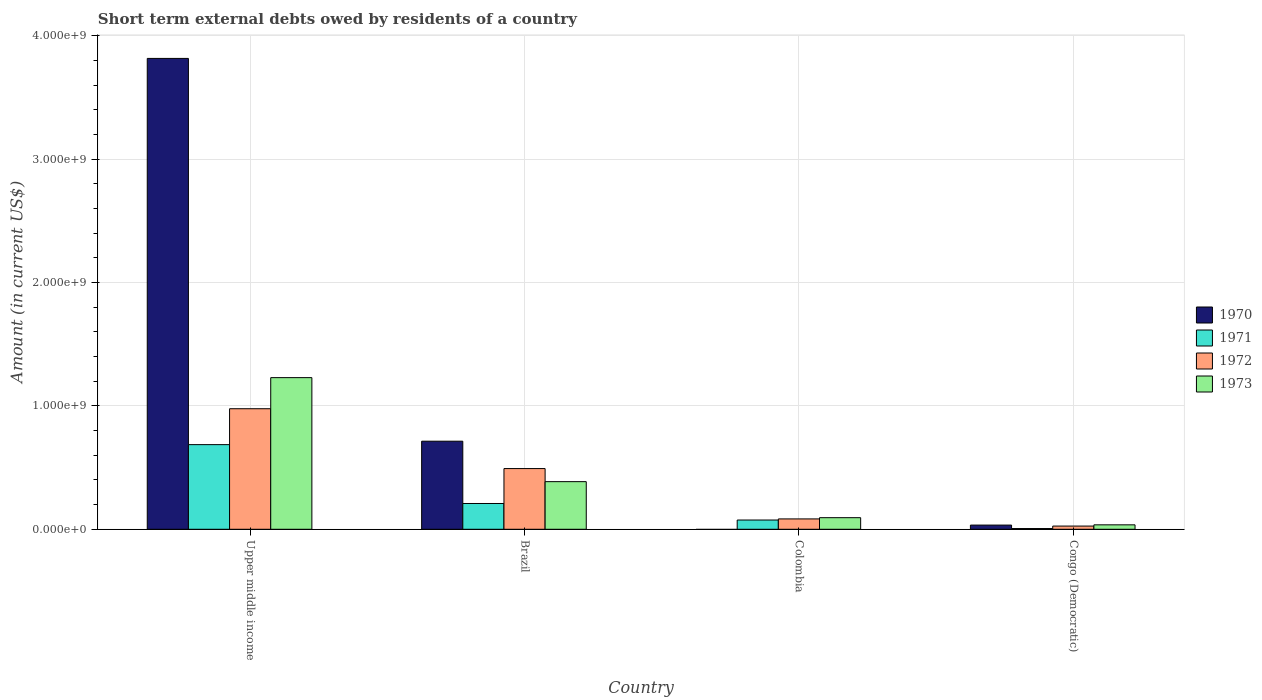How many bars are there on the 3rd tick from the left?
Your answer should be very brief. 3. How many bars are there on the 4th tick from the right?
Provide a succinct answer. 4. In how many cases, is the number of bars for a given country not equal to the number of legend labels?
Make the answer very short. 1. What is the amount of short-term external debts owed by residents in 1973 in Brazil?
Give a very brief answer. 3.86e+08. Across all countries, what is the maximum amount of short-term external debts owed by residents in 1971?
Make the answer very short. 6.86e+08. In which country was the amount of short-term external debts owed by residents in 1973 maximum?
Your answer should be compact. Upper middle income. What is the total amount of short-term external debts owed by residents in 1971 in the graph?
Ensure brevity in your answer.  9.76e+08. What is the difference between the amount of short-term external debts owed by residents in 1973 in Brazil and that in Colombia?
Make the answer very short. 2.92e+08. What is the difference between the amount of short-term external debts owed by residents in 1973 in Upper middle income and the amount of short-term external debts owed by residents in 1972 in Brazil?
Offer a terse response. 7.37e+08. What is the average amount of short-term external debts owed by residents in 1972 per country?
Give a very brief answer. 3.95e+08. What is the difference between the amount of short-term external debts owed by residents of/in 1972 and amount of short-term external debts owed by residents of/in 1970 in Congo (Democratic)?
Ensure brevity in your answer.  -8.00e+06. In how many countries, is the amount of short-term external debts owed by residents in 1970 greater than 1400000000 US$?
Your answer should be compact. 1. What is the ratio of the amount of short-term external debts owed by residents in 1973 in Colombia to that in Congo (Democratic)?
Your response must be concise. 2.61. What is the difference between the highest and the second highest amount of short-term external debts owed by residents in 1971?
Make the answer very short. 4.77e+08. What is the difference between the highest and the lowest amount of short-term external debts owed by residents in 1971?
Provide a short and direct response. 6.80e+08. Is it the case that in every country, the sum of the amount of short-term external debts owed by residents in 1972 and amount of short-term external debts owed by residents in 1971 is greater than the sum of amount of short-term external debts owed by residents in 1973 and amount of short-term external debts owed by residents in 1970?
Your response must be concise. No. Are the values on the major ticks of Y-axis written in scientific E-notation?
Give a very brief answer. Yes. Does the graph contain grids?
Give a very brief answer. Yes. Where does the legend appear in the graph?
Provide a succinct answer. Center right. How are the legend labels stacked?
Keep it short and to the point. Vertical. What is the title of the graph?
Your response must be concise. Short term external debts owed by residents of a country. Does "1994" appear as one of the legend labels in the graph?
Ensure brevity in your answer.  No. What is the label or title of the X-axis?
Provide a succinct answer. Country. What is the Amount (in current US$) of 1970 in Upper middle income?
Give a very brief answer. 3.82e+09. What is the Amount (in current US$) in 1971 in Upper middle income?
Provide a short and direct response. 6.86e+08. What is the Amount (in current US$) of 1972 in Upper middle income?
Ensure brevity in your answer.  9.77e+08. What is the Amount (in current US$) in 1973 in Upper middle income?
Ensure brevity in your answer.  1.23e+09. What is the Amount (in current US$) in 1970 in Brazil?
Offer a very short reply. 7.14e+08. What is the Amount (in current US$) of 1971 in Brazil?
Offer a terse response. 2.09e+08. What is the Amount (in current US$) in 1972 in Brazil?
Your answer should be compact. 4.92e+08. What is the Amount (in current US$) of 1973 in Brazil?
Offer a terse response. 3.86e+08. What is the Amount (in current US$) of 1970 in Colombia?
Your answer should be compact. 0. What is the Amount (in current US$) of 1971 in Colombia?
Offer a very short reply. 7.50e+07. What is the Amount (in current US$) of 1972 in Colombia?
Offer a very short reply. 8.40e+07. What is the Amount (in current US$) in 1973 in Colombia?
Ensure brevity in your answer.  9.40e+07. What is the Amount (in current US$) of 1970 in Congo (Democratic)?
Make the answer very short. 3.40e+07. What is the Amount (in current US$) in 1971 in Congo (Democratic)?
Make the answer very short. 6.00e+06. What is the Amount (in current US$) of 1972 in Congo (Democratic)?
Offer a terse response. 2.60e+07. What is the Amount (in current US$) of 1973 in Congo (Democratic)?
Your answer should be very brief. 3.60e+07. Across all countries, what is the maximum Amount (in current US$) in 1970?
Provide a succinct answer. 3.82e+09. Across all countries, what is the maximum Amount (in current US$) of 1971?
Provide a succinct answer. 6.86e+08. Across all countries, what is the maximum Amount (in current US$) of 1972?
Your answer should be very brief. 9.77e+08. Across all countries, what is the maximum Amount (in current US$) of 1973?
Give a very brief answer. 1.23e+09. Across all countries, what is the minimum Amount (in current US$) in 1970?
Keep it short and to the point. 0. Across all countries, what is the minimum Amount (in current US$) of 1972?
Give a very brief answer. 2.60e+07. Across all countries, what is the minimum Amount (in current US$) of 1973?
Make the answer very short. 3.60e+07. What is the total Amount (in current US$) of 1970 in the graph?
Offer a very short reply. 4.56e+09. What is the total Amount (in current US$) in 1971 in the graph?
Provide a succinct answer. 9.76e+08. What is the total Amount (in current US$) in 1972 in the graph?
Provide a short and direct response. 1.58e+09. What is the total Amount (in current US$) of 1973 in the graph?
Give a very brief answer. 1.75e+09. What is the difference between the Amount (in current US$) in 1970 in Upper middle income and that in Brazil?
Provide a short and direct response. 3.10e+09. What is the difference between the Amount (in current US$) of 1971 in Upper middle income and that in Brazil?
Make the answer very short. 4.77e+08. What is the difference between the Amount (in current US$) of 1972 in Upper middle income and that in Brazil?
Your response must be concise. 4.85e+08. What is the difference between the Amount (in current US$) of 1973 in Upper middle income and that in Brazil?
Offer a terse response. 8.43e+08. What is the difference between the Amount (in current US$) in 1971 in Upper middle income and that in Colombia?
Your answer should be compact. 6.11e+08. What is the difference between the Amount (in current US$) in 1972 in Upper middle income and that in Colombia?
Your answer should be very brief. 8.93e+08. What is the difference between the Amount (in current US$) of 1973 in Upper middle income and that in Colombia?
Ensure brevity in your answer.  1.14e+09. What is the difference between the Amount (in current US$) in 1970 in Upper middle income and that in Congo (Democratic)?
Keep it short and to the point. 3.78e+09. What is the difference between the Amount (in current US$) of 1971 in Upper middle income and that in Congo (Democratic)?
Offer a terse response. 6.80e+08. What is the difference between the Amount (in current US$) in 1972 in Upper middle income and that in Congo (Democratic)?
Keep it short and to the point. 9.51e+08. What is the difference between the Amount (in current US$) in 1973 in Upper middle income and that in Congo (Democratic)?
Provide a succinct answer. 1.19e+09. What is the difference between the Amount (in current US$) of 1971 in Brazil and that in Colombia?
Provide a short and direct response. 1.34e+08. What is the difference between the Amount (in current US$) of 1972 in Brazil and that in Colombia?
Keep it short and to the point. 4.08e+08. What is the difference between the Amount (in current US$) in 1973 in Brazil and that in Colombia?
Ensure brevity in your answer.  2.92e+08. What is the difference between the Amount (in current US$) of 1970 in Brazil and that in Congo (Democratic)?
Offer a very short reply. 6.80e+08. What is the difference between the Amount (in current US$) of 1971 in Brazil and that in Congo (Democratic)?
Your answer should be very brief. 2.03e+08. What is the difference between the Amount (in current US$) of 1972 in Brazil and that in Congo (Democratic)?
Your response must be concise. 4.66e+08. What is the difference between the Amount (in current US$) in 1973 in Brazil and that in Congo (Democratic)?
Offer a very short reply. 3.50e+08. What is the difference between the Amount (in current US$) of 1971 in Colombia and that in Congo (Democratic)?
Make the answer very short. 6.90e+07. What is the difference between the Amount (in current US$) of 1972 in Colombia and that in Congo (Democratic)?
Keep it short and to the point. 5.80e+07. What is the difference between the Amount (in current US$) of 1973 in Colombia and that in Congo (Democratic)?
Give a very brief answer. 5.80e+07. What is the difference between the Amount (in current US$) in 1970 in Upper middle income and the Amount (in current US$) in 1971 in Brazil?
Offer a terse response. 3.61e+09. What is the difference between the Amount (in current US$) of 1970 in Upper middle income and the Amount (in current US$) of 1972 in Brazil?
Make the answer very short. 3.32e+09. What is the difference between the Amount (in current US$) of 1970 in Upper middle income and the Amount (in current US$) of 1973 in Brazil?
Keep it short and to the point. 3.43e+09. What is the difference between the Amount (in current US$) in 1971 in Upper middle income and the Amount (in current US$) in 1972 in Brazil?
Ensure brevity in your answer.  1.94e+08. What is the difference between the Amount (in current US$) of 1971 in Upper middle income and the Amount (in current US$) of 1973 in Brazil?
Your response must be concise. 3.00e+08. What is the difference between the Amount (in current US$) in 1972 in Upper middle income and the Amount (in current US$) in 1973 in Brazil?
Keep it short and to the point. 5.91e+08. What is the difference between the Amount (in current US$) of 1970 in Upper middle income and the Amount (in current US$) of 1971 in Colombia?
Provide a succinct answer. 3.74e+09. What is the difference between the Amount (in current US$) of 1970 in Upper middle income and the Amount (in current US$) of 1972 in Colombia?
Provide a succinct answer. 3.73e+09. What is the difference between the Amount (in current US$) of 1970 in Upper middle income and the Amount (in current US$) of 1973 in Colombia?
Make the answer very short. 3.72e+09. What is the difference between the Amount (in current US$) of 1971 in Upper middle income and the Amount (in current US$) of 1972 in Colombia?
Keep it short and to the point. 6.02e+08. What is the difference between the Amount (in current US$) of 1971 in Upper middle income and the Amount (in current US$) of 1973 in Colombia?
Your answer should be very brief. 5.92e+08. What is the difference between the Amount (in current US$) in 1972 in Upper middle income and the Amount (in current US$) in 1973 in Colombia?
Provide a short and direct response. 8.83e+08. What is the difference between the Amount (in current US$) in 1970 in Upper middle income and the Amount (in current US$) in 1971 in Congo (Democratic)?
Give a very brief answer. 3.81e+09. What is the difference between the Amount (in current US$) of 1970 in Upper middle income and the Amount (in current US$) of 1972 in Congo (Democratic)?
Your answer should be very brief. 3.79e+09. What is the difference between the Amount (in current US$) in 1970 in Upper middle income and the Amount (in current US$) in 1973 in Congo (Democratic)?
Provide a short and direct response. 3.78e+09. What is the difference between the Amount (in current US$) of 1971 in Upper middle income and the Amount (in current US$) of 1972 in Congo (Democratic)?
Ensure brevity in your answer.  6.60e+08. What is the difference between the Amount (in current US$) of 1971 in Upper middle income and the Amount (in current US$) of 1973 in Congo (Democratic)?
Your answer should be compact. 6.50e+08. What is the difference between the Amount (in current US$) in 1972 in Upper middle income and the Amount (in current US$) in 1973 in Congo (Democratic)?
Give a very brief answer. 9.41e+08. What is the difference between the Amount (in current US$) in 1970 in Brazil and the Amount (in current US$) in 1971 in Colombia?
Keep it short and to the point. 6.39e+08. What is the difference between the Amount (in current US$) in 1970 in Brazil and the Amount (in current US$) in 1972 in Colombia?
Provide a succinct answer. 6.30e+08. What is the difference between the Amount (in current US$) of 1970 in Brazil and the Amount (in current US$) of 1973 in Colombia?
Your answer should be very brief. 6.20e+08. What is the difference between the Amount (in current US$) of 1971 in Brazil and the Amount (in current US$) of 1972 in Colombia?
Provide a short and direct response. 1.25e+08. What is the difference between the Amount (in current US$) in 1971 in Brazil and the Amount (in current US$) in 1973 in Colombia?
Make the answer very short. 1.15e+08. What is the difference between the Amount (in current US$) of 1972 in Brazil and the Amount (in current US$) of 1973 in Colombia?
Your response must be concise. 3.98e+08. What is the difference between the Amount (in current US$) in 1970 in Brazil and the Amount (in current US$) in 1971 in Congo (Democratic)?
Ensure brevity in your answer.  7.08e+08. What is the difference between the Amount (in current US$) of 1970 in Brazil and the Amount (in current US$) of 1972 in Congo (Democratic)?
Your response must be concise. 6.88e+08. What is the difference between the Amount (in current US$) in 1970 in Brazil and the Amount (in current US$) in 1973 in Congo (Democratic)?
Ensure brevity in your answer.  6.78e+08. What is the difference between the Amount (in current US$) in 1971 in Brazil and the Amount (in current US$) in 1972 in Congo (Democratic)?
Your response must be concise. 1.83e+08. What is the difference between the Amount (in current US$) of 1971 in Brazil and the Amount (in current US$) of 1973 in Congo (Democratic)?
Offer a terse response. 1.73e+08. What is the difference between the Amount (in current US$) in 1972 in Brazil and the Amount (in current US$) in 1973 in Congo (Democratic)?
Offer a very short reply. 4.56e+08. What is the difference between the Amount (in current US$) of 1971 in Colombia and the Amount (in current US$) of 1972 in Congo (Democratic)?
Provide a succinct answer. 4.90e+07. What is the difference between the Amount (in current US$) of 1971 in Colombia and the Amount (in current US$) of 1973 in Congo (Democratic)?
Your answer should be very brief. 3.90e+07. What is the difference between the Amount (in current US$) in 1972 in Colombia and the Amount (in current US$) in 1973 in Congo (Democratic)?
Provide a succinct answer. 4.80e+07. What is the average Amount (in current US$) of 1970 per country?
Offer a terse response. 1.14e+09. What is the average Amount (in current US$) of 1971 per country?
Your response must be concise. 2.44e+08. What is the average Amount (in current US$) in 1972 per country?
Provide a short and direct response. 3.95e+08. What is the average Amount (in current US$) in 1973 per country?
Your answer should be compact. 4.36e+08. What is the difference between the Amount (in current US$) of 1970 and Amount (in current US$) of 1971 in Upper middle income?
Give a very brief answer. 3.13e+09. What is the difference between the Amount (in current US$) in 1970 and Amount (in current US$) in 1972 in Upper middle income?
Provide a short and direct response. 2.84e+09. What is the difference between the Amount (in current US$) of 1970 and Amount (in current US$) of 1973 in Upper middle income?
Your answer should be compact. 2.59e+09. What is the difference between the Amount (in current US$) of 1971 and Amount (in current US$) of 1972 in Upper middle income?
Offer a terse response. -2.91e+08. What is the difference between the Amount (in current US$) in 1971 and Amount (in current US$) in 1973 in Upper middle income?
Ensure brevity in your answer.  -5.43e+08. What is the difference between the Amount (in current US$) of 1972 and Amount (in current US$) of 1973 in Upper middle income?
Offer a very short reply. -2.52e+08. What is the difference between the Amount (in current US$) in 1970 and Amount (in current US$) in 1971 in Brazil?
Offer a very short reply. 5.05e+08. What is the difference between the Amount (in current US$) of 1970 and Amount (in current US$) of 1972 in Brazil?
Provide a succinct answer. 2.22e+08. What is the difference between the Amount (in current US$) of 1970 and Amount (in current US$) of 1973 in Brazil?
Keep it short and to the point. 3.28e+08. What is the difference between the Amount (in current US$) of 1971 and Amount (in current US$) of 1972 in Brazil?
Make the answer very short. -2.83e+08. What is the difference between the Amount (in current US$) in 1971 and Amount (in current US$) in 1973 in Brazil?
Your answer should be very brief. -1.77e+08. What is the difference between the Amount (in current US$) in 1972 and Amount (in current US$) in 1973 in Brazil?
Your answer should be compact. 1.06e+08. What is the difference between the Amount (in current US$) of 1971 and Amount (in current US$) of 1972 in Colombia?
Your response must be concise. -9.00e+06. What is the difference between the Amount (in current US$) in 1971 and Amount (in current US$) in 1973 in Colombia?
Provide a short and direct response. -1.90e+07. What is the difference between the Amount (in current US$) in 1972 and Amount (in current US$) in 1973 in Colombia?
Your response must be concise. -1.00e+07. What is the difference between the Amount (in current US$) in 1970 and Amount (in current US$) in 1971 in Congo (Democratic)?
Offer a terse response. 2.80e+07. What is the difference between the Amount (in current US$) of 1970 and Amount (in current US$) of 1972 in Congo (Democratic)?
Your response must be concise. 8.00e+06. What is the difference between the Amount (in current US$) of 1970 and Amount (in current US$) of 1973 in Congo (Democratic)?
Give a very brief answer. -2.00e+06. What is the difference between the Amount (in current US$) in 1971 and Amount (in current US$) in 1972 in Congo (Democratic)?
Offer a very short reply. -2.00e+07. What is the difference between the Amount (in current US$) in 1971 and Amount (in current US$) in 1973 in Congo (Democratic)?
Offer a very short reply. -3.00e+07. What is the difference between the Amount (in current US$) of 1972 and Amount (in current US$) of 1973 in Congo (Democratic)?
Offer a very short reply. -1.00e+07. What is the ratio of the Amount (in current US$) of 1970 in Upper middle income to that in Brazil?
Keep it short and to the point. 5.35. What is the ratio of the Amount (in current US$) of 1971 in Upper middle income to that in Brazil?
Keep it short and to the point. 3.28. What is the ratio of the Amount (in current US$) of 1972 in Upper middle income to that in Brazil?
Your answer should be compact. 1.99. What is the ratio of the Amount (in current US$) of 1973 in Upper middle income to that in Brazil?
Offer a very short reply. 3.18. What is the ratio of the Amount (in current US$) of 1971 in Upper middle income to that in Colombia?
Your response must be concise. 9.15. What is the ratio of the Amount (in current US$) of 1972 in Upper middle income to that in Colombia?
Offer a very short reply. 11.63. What is the ratio of the Amount (in current US$) of 1973 in Upper middle income to that in Colombia?
Provide a succinct answer. 13.08. What is the ratio of the Amount (in current US$) in 1970 in Upper middle income to that in Congo (Democratic)?
Keep it short and to the point. 112.25. What is the ratio of the Amount (in current US$) of 1971 in Upper middle income to that in Congo (Democratic)?
Keep it short and to the point. 114.35. What is the ratio of the Amount (in current US$) of 1972 in Upper middle income to that in Congo (Democratic)?
Your response must be concise. 37.58. What is the ratio of the Amount (in current US$) of 1973 in Upper middle income to that in Congo (Democratic)?
Keep it short and to the point. 34.14. What is the ratio of the Amount (in current US$) in 1971 in Brazil to that in Colombia?
Offer a terse response. 2.79. What is the ratio of the Amount (in current US$) of 1972 in Brazil to that in Colombia?
Your answer should be very brief. 5.86. What is the ratio of the Amount (in current US$) of 1973 in Brazil to that in Colombia?
Make the answer very short. 4.11. What is the ratio of the Amount (in current US$) in 1971 in Brazil to that in Congo (Democratic)?
Make the answer very short. 34.83. What is the ratio of the Amount (in current US$) in 1972 in Brazil to that in Congo (Democratic)?
Your answer should be very brief. 18.92. What is the ratio of the Amount (in current US$) in 1973 in Brazil to that in Congo (Democratic)?
Your answer should be compact. 10.72. What is the ratio of the Amount (in current US$) of 1972 in Colombia to that in Congo (Democratic)?
Offer a very short reply. 3.23. What is the ratio of the Amount (in current US$) in 1973 in Colombia to that in Congo (Democratic)?
Ensure brevity in your answer.  2.61. What is the difference between the highest and the second highest Amount (in current US$) in 1970?
Ensure brevity in your answer.  3.10e+09. What is the difference between the highest and the second highest Amount (in current US$) in 1971?
Provide a succinct answer. 4.77e+08. What is the difference between the highest and the second highest Amount (in current US$) of 1972?
Offer a very short reply. 4.85e+08. What is the difference between the highest and the second highest Amount (in current US$) of 1973?
Ensure brevity in your answer.  8.43e+08. What is the difference between the highest and the lowest Amount (in current US$) of 1970?
Keep it short and to the point. 3.82e+09. What is the difference between the highest and the lowest Amount (in current US$) of 1971?
Your answer should be very brief. 6.80e+08. What is the difference between the highest and the lowest Amount (in current US$) of 1972?
Offer a terse response. 9.51e+08. What is the difference between the highest and the lowest Amount (in current US$) of 1973?
Your answer should be compact. 1.19e+09. 